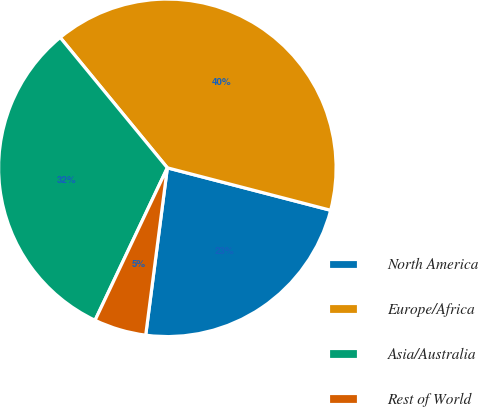<chart> <loc_0><loc_0><loc_500><loc_500><pie_chart><fcel>North America<fcel>Europe/Africa<fcel>Asia/Australia<fcel>Rest of World<nl><fcel>23.0%<fcel>40.0%<fcel>32.0%<fcel>5.0%<nl></chart> 